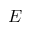<formula> <loc_0><loc_0><loc_500><loc_500>E</formula> 